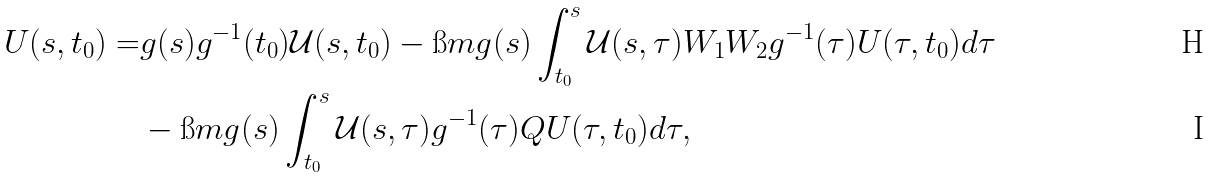<formula> <loc_0><loc_0><loc_500><loc_500>U ( s , t _ { 0 } ) = & g ( s ) g ^ { - 1 } ( t _ { 0 } ) \mathcal { U } ( s , t _ { 0 } ) - \i m g ( s ) \int _ { t _ { 0 } } ^ { s } \mathcal { U } ( s , \tau ) W _ { 1 } W _ { 2 } g ^ { - 1 } ( \tau ) U ( \tau , t _ { 0 } ) d \tau \\ & - \i m g ( s ) \int _ { t _ { 0 } } ^ { s } \mathcal { U } ( s , \tau ) g ^ { - 1 } ( \tau ) Q U ( \tau , t _ { 0 } ) d \tau ,</formula> 